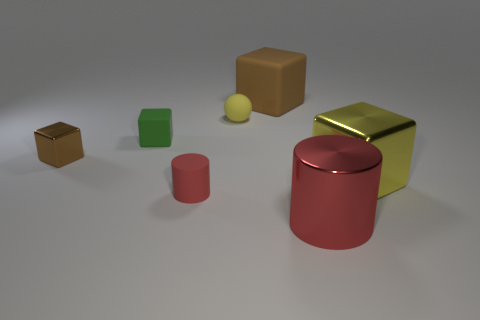Add 2 large brown things. How many objects exist? 9 Subtract all cylinders. How many objects are left? 5 Subtract all small brown objects. Subtract all red matte things. How many objects are left? 5 Add 3 yellow matte spheres. How many yellow matte spheres are left? 4 Add 5 large yellow shiny things. How many large yellow shiny things exist? 6 Subtract 0 gray cubes. How many objects are left? 7 